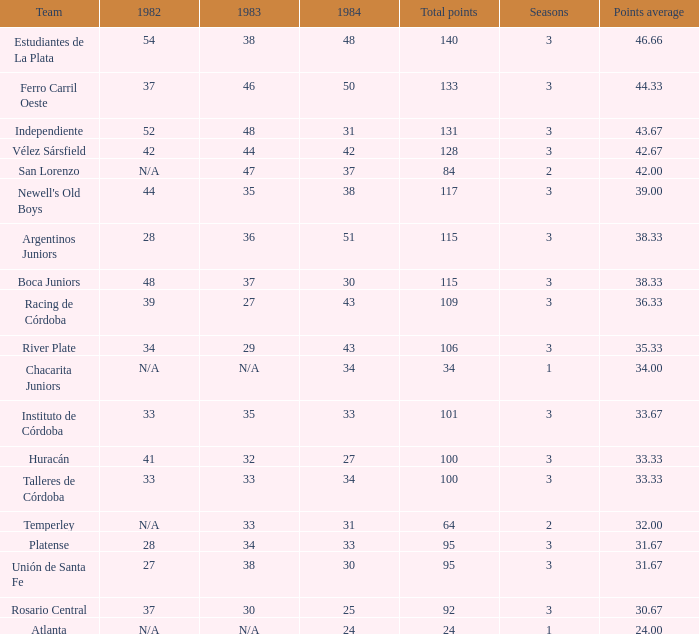What was the score in 1984 for a team that has a total of 100 points or more and has played in over three seasons? None. 